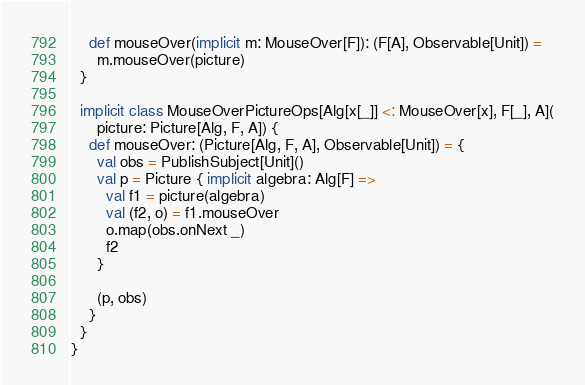Convert code to text. <code><loc_0><loc_0><loc_500><loc_500><_Scala_>    def mouseOver(implicit m: MouseOver[F]): (F[A], Observable[Unit]) =
      m.mouseOver(picture)
  }

  implicit class MouseOverPictureOps[Alg[x[_]] <: MouseOver[x], F[_], A](
      picture: Picture[Alg, F, A]) {
    def mouseOver: (Picture[Alg, F, A], Observable[Unit]) = {
      val obs = PublishSubject[Unit]()
      val p = Picture { implicit algebra: Alg[F] =>
        val f1 = picture(algebra)
        val (f2, o) = f1.mouseOver
        o.map(obs.onNext _)
        f2
      }

      (p, obs)
    }
  }
}
</code> 